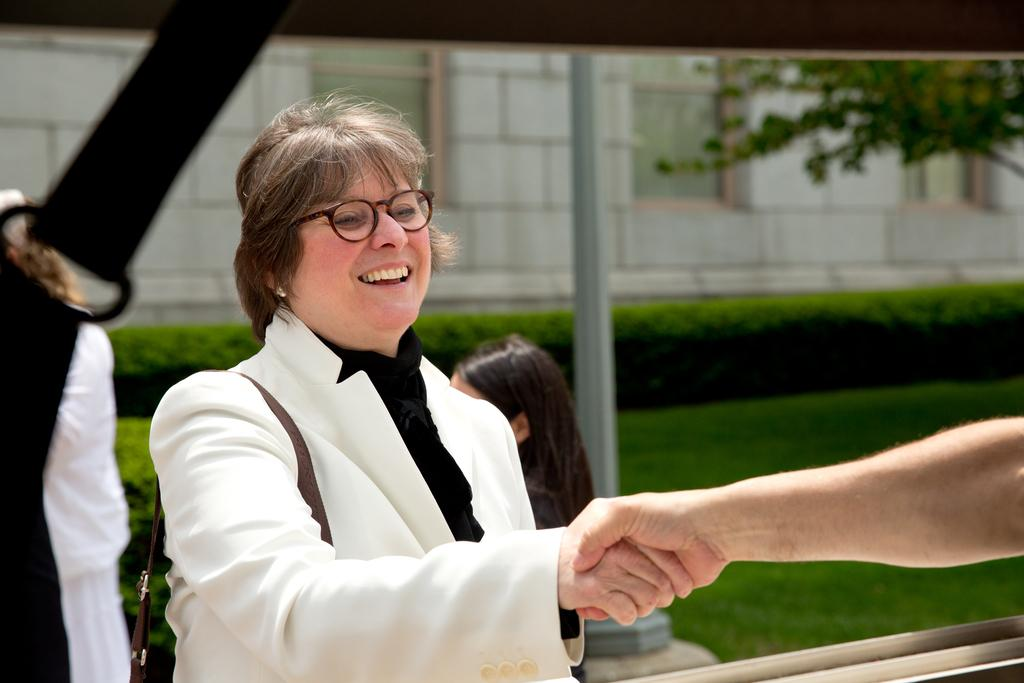How many people are in the image? There are people in the image, but the exact number is not specified. What type of surface is visible on the ground in the image? The ground is visible in the image, but the specific type of surface is not mentioned. What type of vegetation is present in the image? There is grass and plants in the image. What type of structure can be seen in the image? There is a building with windows in the image. What other object is present in the image? There is a pole in the image. What type of smell can be detected in the image? There is no information about smells in the image, so it cannot be determined. 